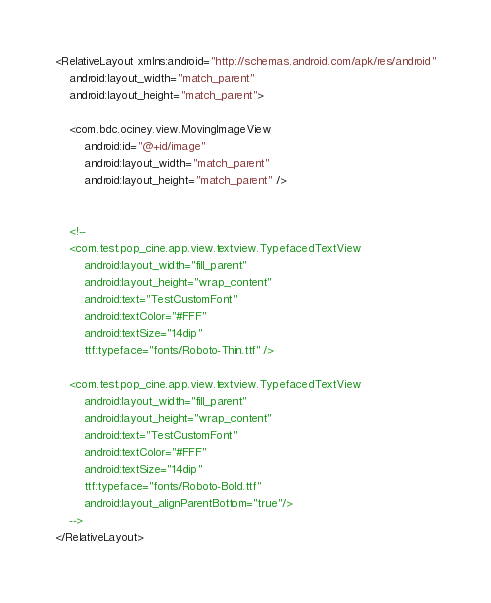<code> <loc_0><loc_0><loc_500><loc_500><_XML_><RelativeLayout xmlns:android="http://schemas.android.com/apk/res/android"
    android:layout_width="match_parent"
    android:layout_height="match_parent">

    <com.bdc.ociney.view.MovingImageView
        android:id="@+id/image"
        android:layout_width="match_parent"
        android:layout_height="match_parent" />


    <!--
    <com.test.pop_cine.app.view.textview.TypefacedTextView
        android:layout_width="fill_parent"
        android:layout_height="wrap_content"
        android:text="TestCustomFont"
        android:textColor="#FFF"
        android:textSize="14dip"
        ttf:typeface="fonts/Roboto-Thin.ttf" />

    <com.test.pop_cine.app.view.textview.TypefacedTextView
        android:layout_width="fill_parent"
        android:layout_height="wrap_content"
        android:text="TestCustomFont"
        android:textColor="#FFF"
        android:textSize="14dip"
        ttf:typeface="fonts/Roboto-Bold.ttf"
        android:layout_alignParentBottom="true"/>
    -->
</RelativeLayout>
</code> 